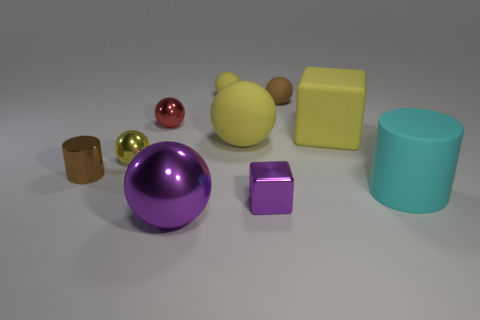There is a tiny thing that is the same color as the big metallic ball; what is its material?
Your answer should be very brief. Metal. There is a small metal thing in front of the cyan rubber thing; does it have the same shape as the brown thing to the right of the large purple sphere?
Make the answer very short. No. There is a object that is in front of the big cyan object and left of the tiny yellow matte sphere; what color is it?
Make the answer very short. Purple. Is the color of the metal cylinder the same as the big sphere that is on the right side of the small yellow matte sphere?
Ensure brevity in your answer.  No. There is a object that is both in front of the large cyan rubber cylinder and to the right of the big purple metallic sphere; what is its size?
Offer a very short reply. Small. What number of other things are there of the same color as the large cube?
Your response must be concise. 3. What is the size of the purple shiny thing to the right of the sphere that is in front of the cylinder to the right of the tiny brown metal thing?
Provide a short and direct response. Small. There is a large block; are there any brown objects behind it?
Offer a terse response. Yes. There is a rubber block; is its size the same as the cylinder to the right of the purple block?
Your answer should be very brief. Yes. How many other objects are there of the same material as the purple cube?
Give a very brief answer. 4. 